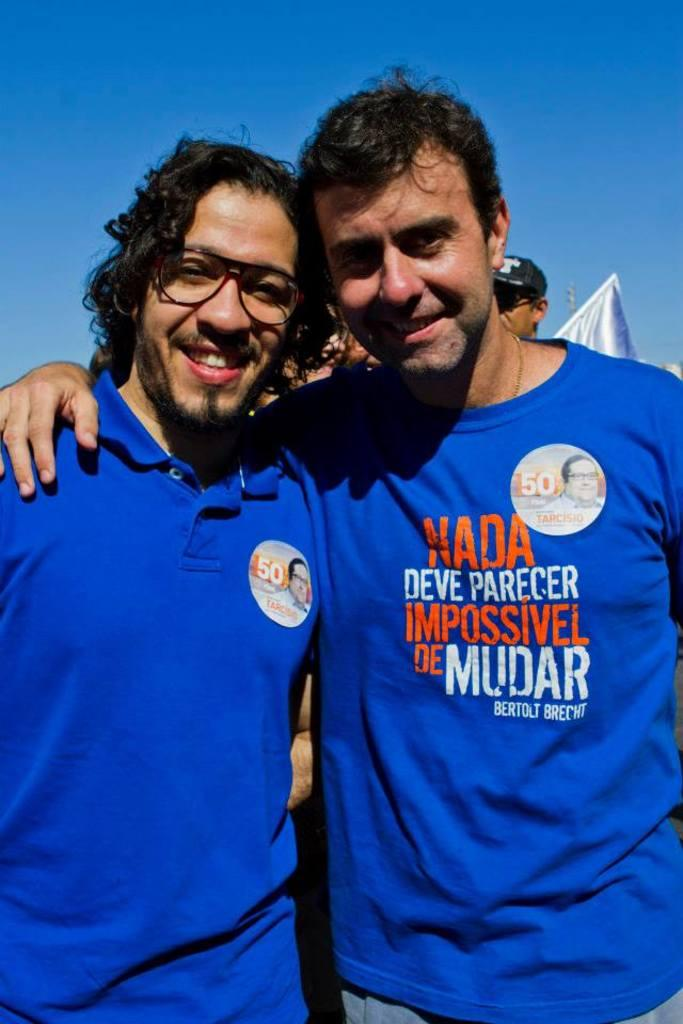How many men are standing in the image? There are two men standing in the image. Can you describe the background of the image? There is a person visible in the background of the image, along with a flag and the sky. What is the condition of the sky in the image? The sky appears to be cloudy in the image. What type of corn is being harvested in the image? There is no corn visible in the image; it features two men standing in front of a background with a person, flag, and cloudy sky. 